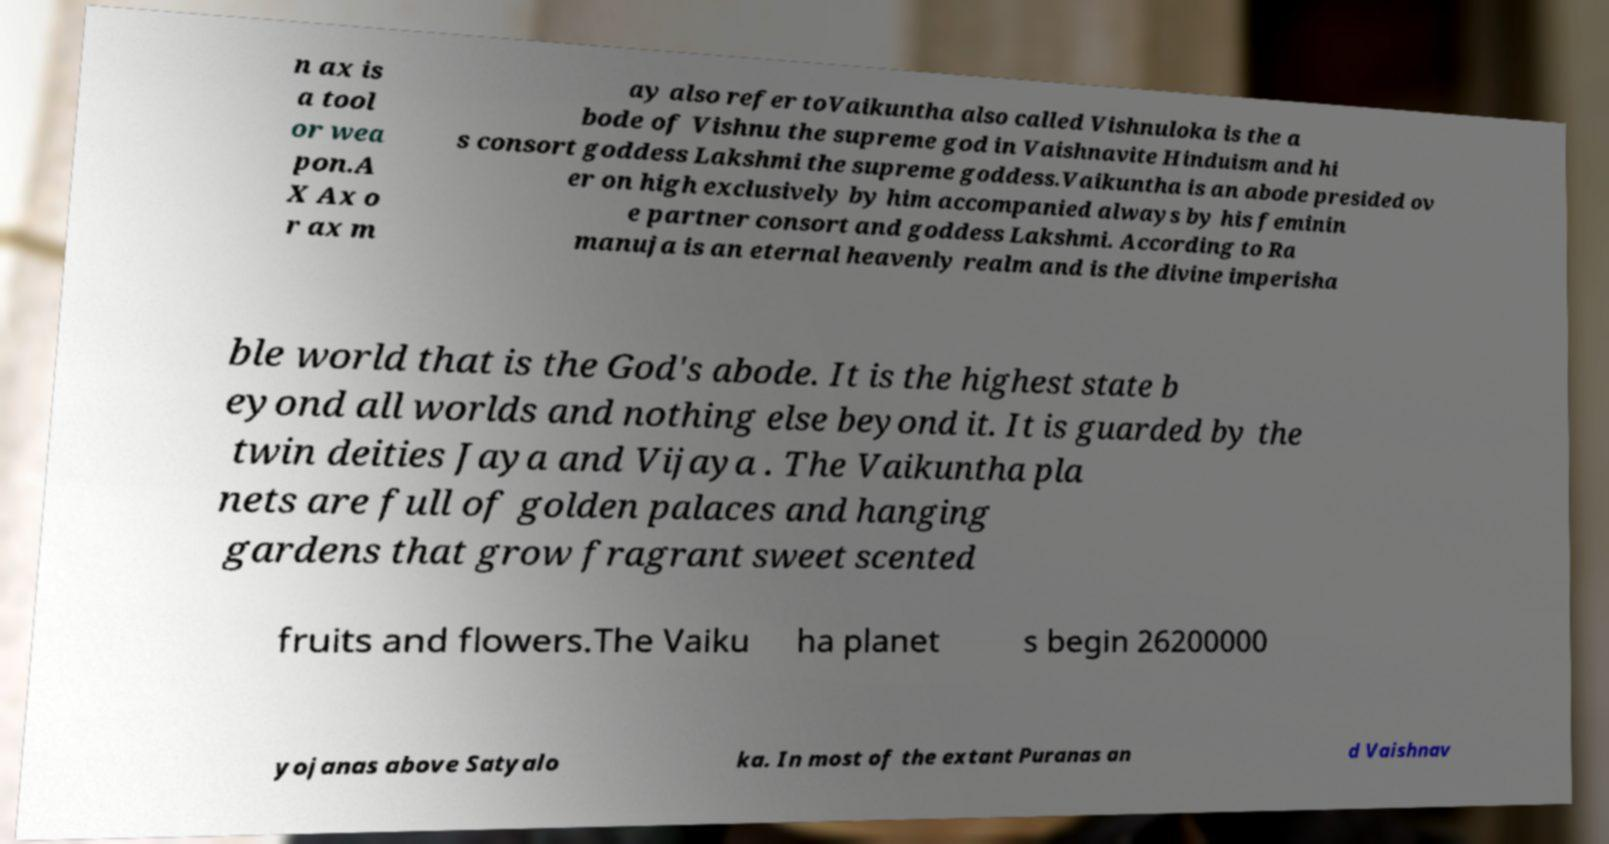Can you accurately transcribe the text from the provided image for me? n ax is a tool or wea pon.A X Ax o r ax m ay also refer toVaikuntha also called Vishnuloka is the a bode of Vishnu the supreme god in Vaishnavite Hinduism and hi s consort goddess Lakshmi the supreme goddess.Vaikuntha is an abode presided ov er on high exclusively by him accompanied always by his feminin e partner consort and goddess Lakshmi. According to Ra manuja is an eternal heavenly realm and is the divine imperisha ble world that is the God's abode. It is the highest state b eyond all worlds and nothing else beyond it. It is guarded by the twin deities Jaya and Vijaya . The Vaikuntha pla nets are full of golden palaces and hanging gardens that grow fragrant sweet scented fruits and flowers.The Vaiku ha planet s begin 26200000 yojanas above Satyalo ka. In most of the extant Puranas an d Vaishnav 